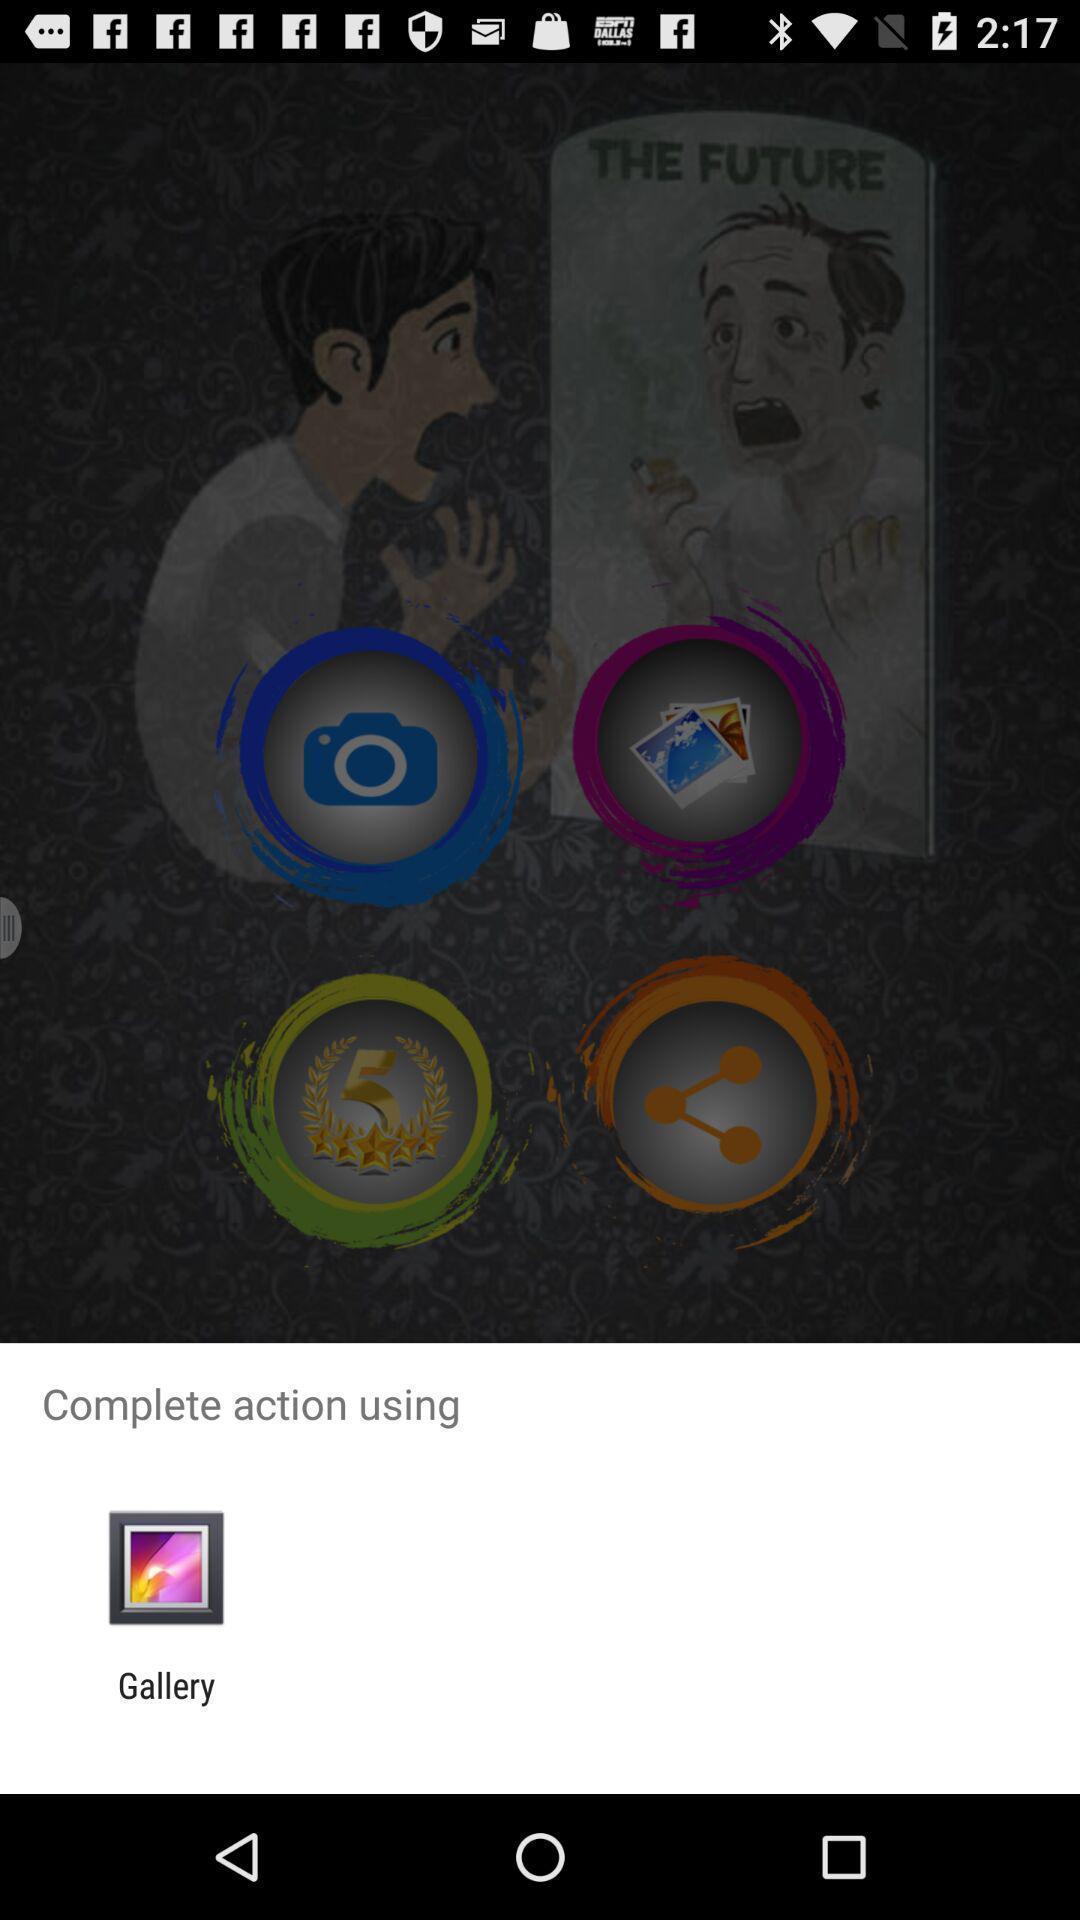What can you discern from this picture? Pop-up displaying to open a folder. 